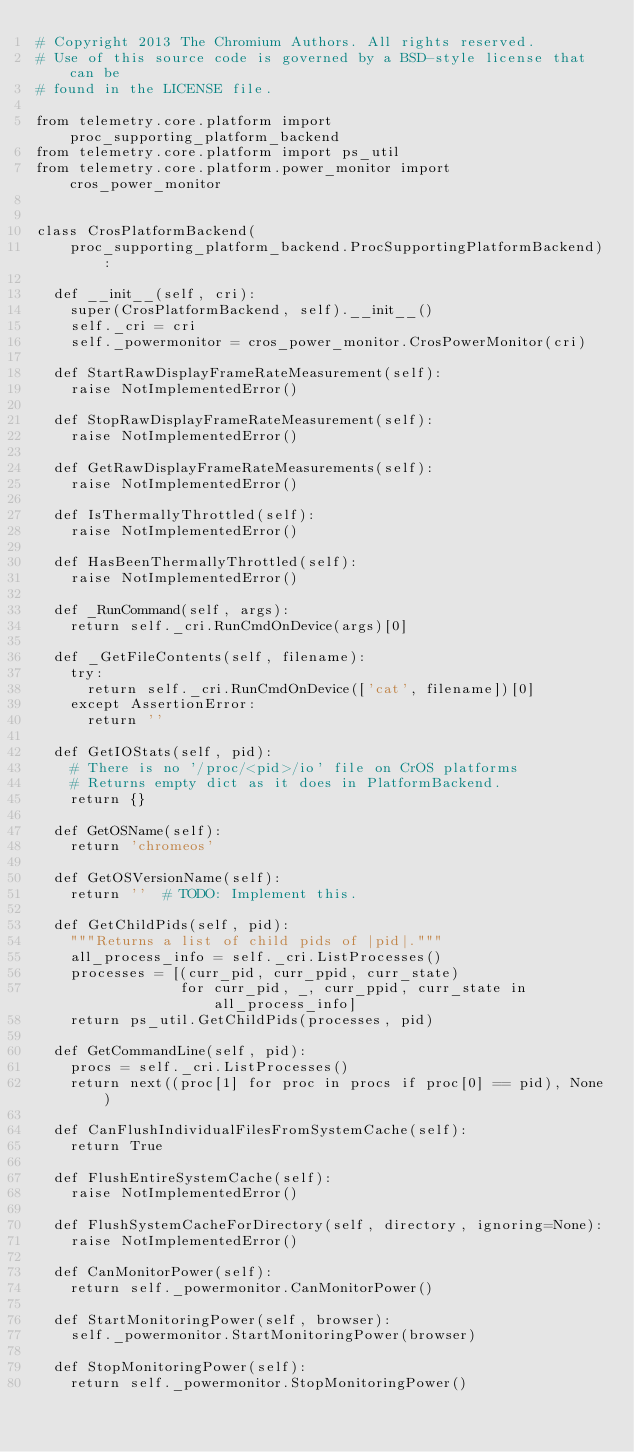<code> <loc_0><loc_0><loc_500><loc_500><_Python_># Copyright 2013 The Chromium Authors. All rights reserved.
# Use of this source code is governed by a BSD-style license that can be
# found in the LICENSE file.

from telemetry.core.platform import proc_supporting_platform_backend
from telemetry.core.platform import ps_util
from telemetry.core.platform.power_monitor import cros_power_monitor


class CrosPlatformBackend(
    proc_supporting_platform_backend.ProcSupportingPlatformBackend):

  def __init__(self, cri):
    super(CrosPlatformBackend, self).__init__()
    self._cri = cri
    self._powermonitor = cros_power_monitor.CrosPowerMonitor(cri)

  def StartRawDisplayFrameRateMeasurement(self):
    raise NotImplementedError()

  def StopRawDisplayFrameRateMeasurement(self):
    raise NotImplementedError()

  def GetRawDisplayFrameRateMeasurements(self):
    raise NotImplementedError()

  def IsThermallyThrottled(self):
    raise NotImplementedError()

  def HasBeenThermallyThrottled(self):
    raise NotImplementedError()

  def _RunCommand(self, args):
    return self._cri.RunCmdOnDevice(args)[0]

  def _GetFileContents(self, filename):
    try:
      return self._cri.RunCmdOnDevice(['cat', filename])[0]
    except AssertionError:
      return ''

  def GetIOStats(self, pid):
    # There is no '/proc/<pid>/io' file on CrOS platforms
    # Returns empty dict as it does in PlatformBackend.
    return {}

  def GetOSName(self):
    return 'chromeos'

  def GetOSVersionName(self):
    return ''  # TODO: Implement this.

  def GetChildPids(self, pid):
    """Returns a list of child pids of |pid|."""
    all_process_info = self._cri.ListProcesses()
    processes = [(curr_pid, curr_ppid, curr_state)
                 for curr_pid, _, curr_ppid, curr_state in all_process_info]
    return ps_util.GetChildPids(processes, pid)

  def GetCommandLine(self, pid):
    procs = self._cri.ListProcesses()
    return next((proc[1] for proc in procs if proc[0] == pid), None)

  def CanFlushIndividualFilesFromSystemCache(self):
    return True

  def FlushEntireSystemCache(self):
    raise NotImplementedError()

  def FlushSystemCacheForDirectory(self, directory, ignoring=None):
    raise NotImplementedError()

  def CanMonitorPower(self):
    return self._powermonitor.CanMonitorPower()

  def StartMonitoringPower(self, browser):
    self._powermonitor.StartMonitoringPower(browser)

  def StopMonitoringPower(self):
    return self._powermonitor.StopMonitoringPower()
</code> 